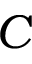<formula> <loc_0><loc_0><loc_500><loc_500>C</formula> 